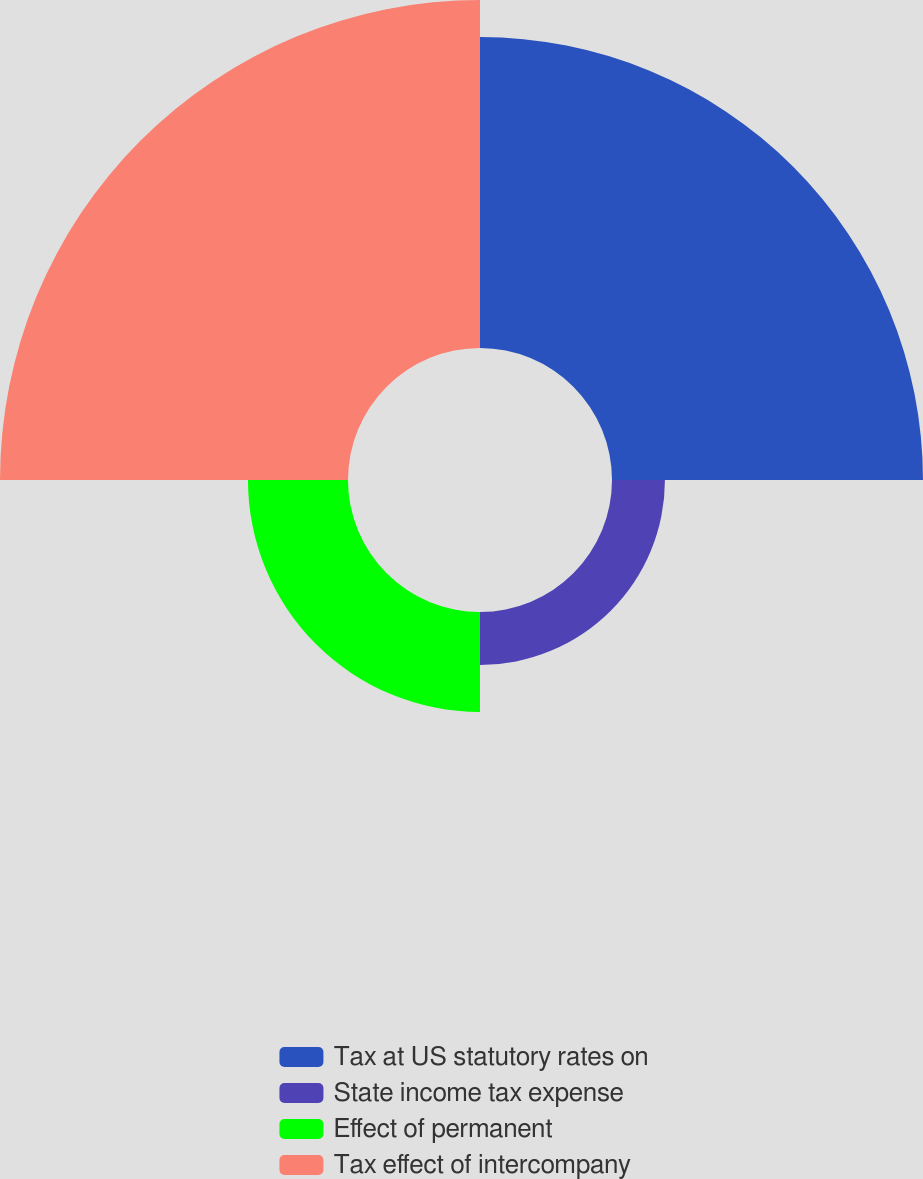Convert chart. <chart><loc_0><loc_0><loc_500><loc_500><pie_chart><fcel>Tax at US statutory rates on<fcel>State income tax expense<fcel>Effect of permanent<fcel>Tax effect of intercompany<nl><fcel>38.3%<fcel>6.52%<fcel>12.32%<fcel>42.86%<nl></chart> 